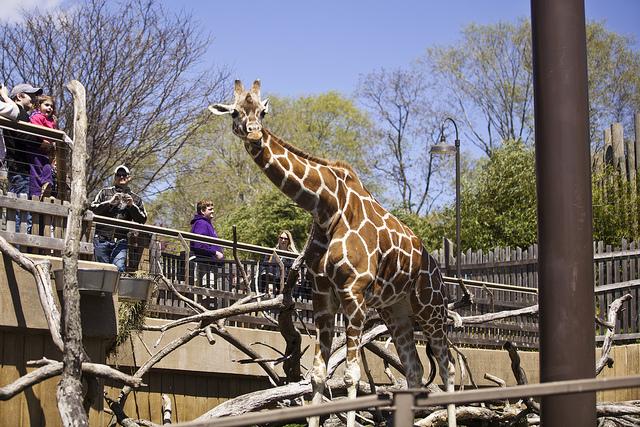In what kind of facility is the giraffe located?
Keep it brief. Zoo. How many people are there?
Write a very short answer. 6. What kind of fencing is in the back?
Keep it brief. Wood. 